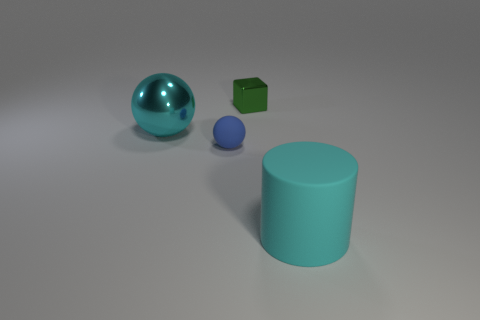Add 3 matte balls. How many objects exist? 7 Subtract all cubes. How many objects are left? 3 Add 1 cyan matte things. How many cyan matte things are left? 2 Add 4 large shiny objects. How many large shiny objects exist? 5 Subtract 0 brown spheres. How many objects are left? 4 Subtract all green metallic cylinders. Subtract all big cyan shiny things. How many objects are left? 3 